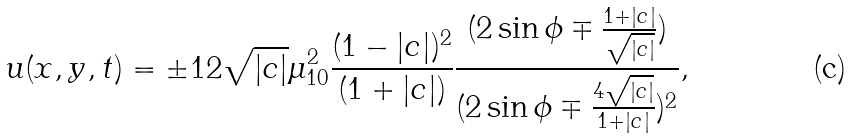Convert formula to latex. <formula><loc_0><loc_0><loc_500><loc_500>u ( x , y , t ) = \pm 1 2 \sqrt { | c | } \mu ^ { 2 } _ { 1 0 } \frac { ( 1 - | c | ) ^ { 2 } } { ( 1 + | c | ) } \frac { ( 2 \sin \phi \mp \frac { 1 + | c | } { \sqrt { | c | } } ) } { ( 2 \sin \phi \mp \frac { 4 \sqrt { | c | } } { 1 + | c | } ) ^ { 2 } } ,</formula> 